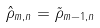<formula> <loc_0><loc_0><loc_500><loc_500>\hat { \rho } _ { m , n } = \tilde { \rho } _ { m - 1 , n }</formula> 